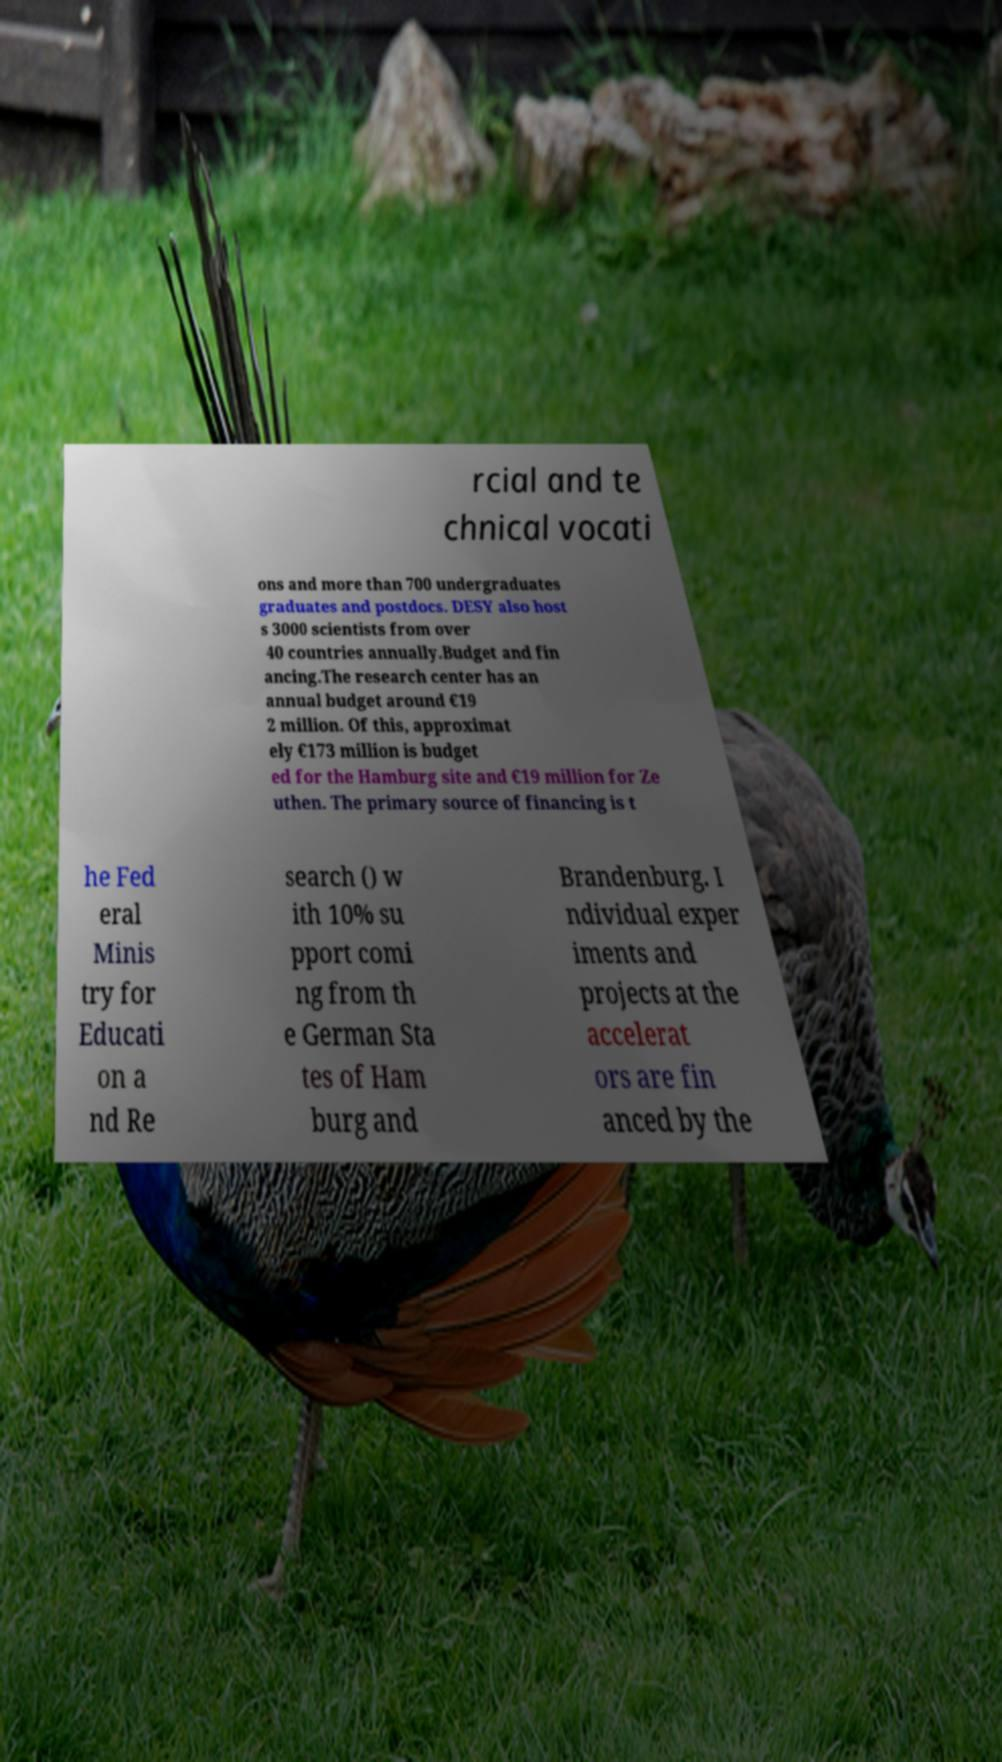What messages or text are displayed in this image? I need them in a readable, typed format. rcial and te chnical vocati ons and more than 700 undergraduates graduates and postdocs. DESY also host s 3000 scientists from over 40 countries annually.Budget and fin ancing.The research center has an annual budget around €19 2 million. Of this, approximat ely €173 million is budget ed for the Hamburg site and €19 million for Ze uthen. The primary source of financing is t he Fed eral Minis try for Educati on a nd Re search () w ith 10% su pport comi ng from th e German Sta tes of Ham burg and Brandenburg. I ndividual exper iments and projects at the accelerat ors are fin anced by the 